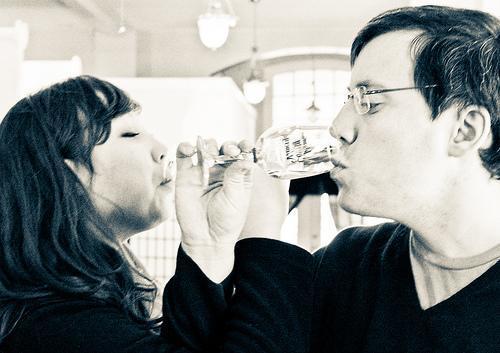How many people are in this photo?
Give a very brief answer. 2. How many ears are visible in this photo?
Give a very brief answer. 1. 